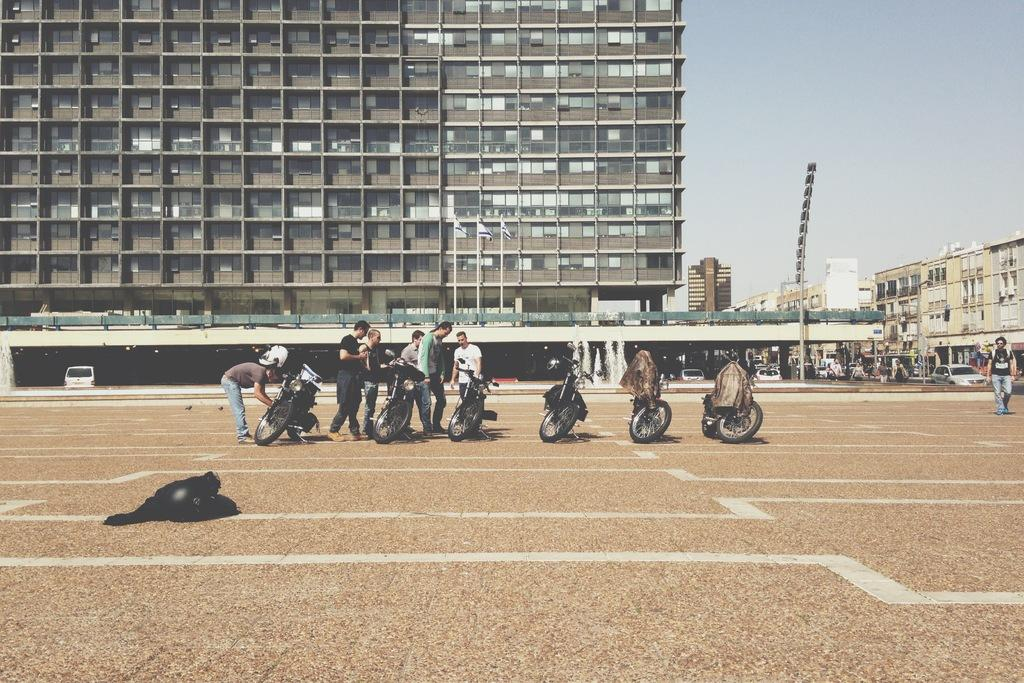What is located in the center of the image? There are people and bikes in the center of the image. What can be seen on the left side of the image? There is an object on the left side of the image. What is visible in the background of the image? There are people, vehicles, buildings, fountains, and the sky visible in the background of the image. How much lead can be found in the bikes in the image? There is no information about the composition of the bikes in the image, so it is impossible to determine the amount of lead present. How many copies of the people in the center of the image are there in the background? There are no copies of the people in the image; each person is unique. 